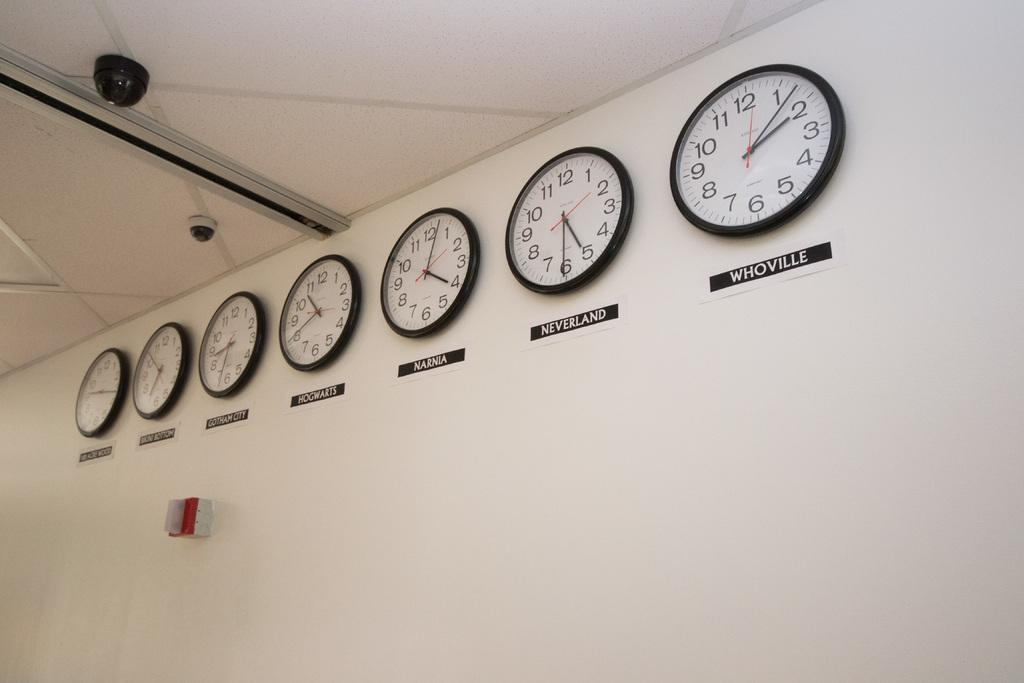<image>
Write a terse but informative summary of the picture. Seven clocks hanging on a wall, the one on the far right is for Whoville. 